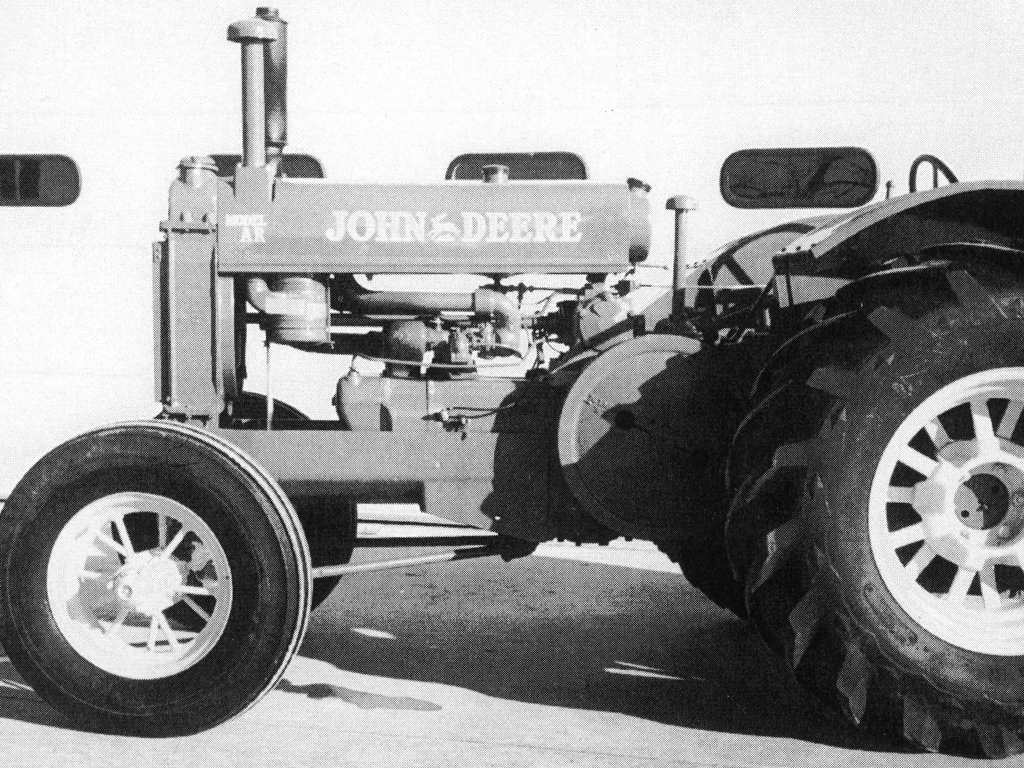What kind of vehicle is shown in the image? The image depicts a vintage tractor. It's a piece of agricultural machinery used mainly for plowing, tilling, and planting fields. The design indicates it might be from an era when such machines were essential for farm productivity. 